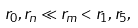<formula> <loc_0><loc_0><loc_500><loc_500>r _ { 0 } , r _ { n } \ll r _ { m } < r _ { 1 } , r _ { 5 } ,</formula> 